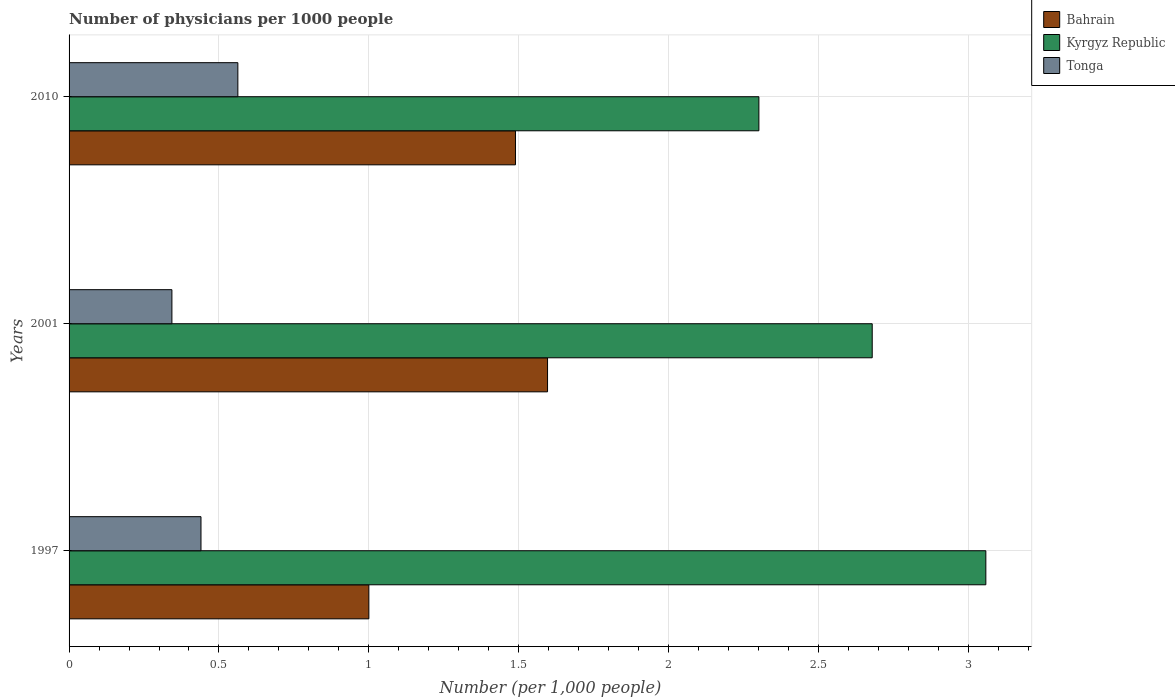How many groups of bars are there?
Your answer should be very brief. 3. Are the number of bars per tick equal to the number of legend labels?
Provide a succinct answer. Yes. What is the label of the 1st group of bars from the top?
Your answer should be compact. 2010. In how many cases, is the number of bars for a given year not equal to the number of legend labels?
Provide a short and direct response. 0. What is the number of physicians in Kyrgyz Republic in 1997?
Provide a succinct answer. 3.06. Across all years, what is the maximum number of physicians in Kyrgyz Republic?
Give a very brief answer. 3.06. Across all years, what is the minimum number of physicians in Kyrgyz Republic?
Provide a succinct answer. 2.3. In which year was the number of physicians in Tonga maximum?
Give a very brief answer. 2010. In which year was the number of physicians in Kyrgyz Republic minimum?
Your answer should be compact. 2010. What is the total number of physicians in Kyrgyz Republic in the graph?
Make the answer very short. 8.04. What is the difference between the number of physicians in Kyrgyz Republic in 2001 and that in 2010?
Provide a short and direct response. 0.38. What is the difference between the number of physicians in Kyrgyz Republic in 1997 and the number of physicians in Bahrain in 2001?
Offer a terse response. 1.46. What is the average number of physicians in Tonga per year?
Keep it short and to the point. 0.45. In the year 2010, what is the difference between the number of physicians in Bahrain and number of physicians in Kyrgyz Republic?
Offer a very short reply. -0.81. What is the ratio of the number of physicians in Tonga in 1997 to that in 2010?
Keep it short and to the point. 0.78. Is the difference between the number of physicians in Bahrain in 1997 and 2001 greater than the difference between the number of physicians in Kyrgyz Republic in 1997 and 2001?
Keep it short and to the point. No. What is the difference between the highest and the second highest number of physicians in Tonga?
Provide a succinct answer. 0.12. What is the difference between the highest and the lowest number of physicians in Tonga?
Keep it short and to the point. 0.22. In how many years, is the number of physicians in Kyrgyz Republic greater than the average number of physicians in Kyrgyz Republic taken over all years?
Your answer should be compact. 1. Is the sum of the number of physicians in Bahrain in 2001 and 2010 greater than the maximum number of physicians in Tonga across all years?
Provide a short and direct response. Yes. What does the 1st bar from the top in 1997 represents?
Keep it short and to the point. Tonga. What does the 2nd bar from the bottom in 1997 represents?
Ensure brevity in your answer.  Kyrgyz Republic. Is it the case that in every year, the sum of the number of physicians in Bahrain and number of physicians in Kyrgyz Republic is greater than the number of physicians in Tonga?
Provide a succinct answer. Yes. How many bars are there?
Ensure brevity in your answer.  9. Are all the bars in the graph horizontal?
Provide a succinct answer. Yes. What is the difference between two consecutive major ticks on the X-axis?
Provide a succinct answer. 0.5. Does the graph contain grids?
Make the answer very short. Yes. Where does the legend appear in the graph?
Ensure brevity in your answer.  Top right. What is the title of the graph?
Offer a terse response. Number of physicians per 1000 people. What is the label or title of the X-axis?
Your response must be concise. Number (per 1,0 people). What is the label or title of the Y-axis?
Provide a succinct answer. Years. What is the Number (per 1,000 people) in Bahrain in 1997?
Your answer should be very brief. 1. What is the Number (per 1,000 people) in Kyrgyz Republic in 1997?
Keep it short and to the point. 3.06. What is the Number (per 1,000 people) in Tonga in 1997?
Ensure brevity in your answer.  0.44. What is the Number (per 1,000 people) in Bahrain in 2001?
Your answer should be very brief. 1.6. What is the Number (per 1,000 people) of Kyrgyz Republic in 2001?
Offer a very short reply. 2.68. What is the Number (per 1,000 people) of Tonga in 2001?
Keep it short and to the point. 0.34. What is the Number (per 1,000 people) of Bahrain in 2010?
Give a very brief answer. 1.49. What is the Number (per 1,000 people) of Kyrgyz Republic in 2010?
Offer a very short reply. 2.3. What is the Number (per 1,000 people) of Tonga in 2010?
Ensure brevity in your answer.  0.56. Across all years, what is the maximum Number (per 1,000 people) of Bahrain?
Make the answer very short. 1.6. Across all years, what is the maximum Number (per 1,000 people) in Kyrgyz Republic?
Make the answer very short. 3.06. Across all years, what is the maximum Number (per 1,000 people) of Tonga?
Your response must be concise. 0.56. Across all years, what is the minimum Number (per 1,000 people) in Kyrgyz Republic?
Your answer should be very brief. 2.3. Across all years, what is the minimum Number (per 1,000 people) in Tonga?
Provide a short and direct response. 0.34. What is the total Number (per 1,000 people) of Bahrain in the graph?
Make the answer very short. 4.08. What is the total Number (per 1,000 people) in Kyrgyz Republic in the graph?
Your response must be concise. 8.04. What is the total Number (per 1,000 people) in Tonga in the graph?
Your answer should be very brief. 1.35. What is the difference between the Number (per 1,000 people) of Bahrain in 1997 and that in 2001?
Provide a short and direct response. -0.6. What is the difference between the Number (per 1,000 people) of Kyrgyz Republic in 1997 and that in 2001?
Your answer should be compact. 0.38. What is the difference between the Number (per 1,000 people) of Tonga in 1997 and that in 2001?
Make the answer very short. 0.1. What is the difference between the Number (per 1,000 people) of Bahrain in 1997 and that in 2010?
Your answer should be compact. -0.49. What is the difference between the Number (per 1,000 people) in Kyrgyz Republic in 1997 and that in 2010?
Provide a short and direct response. 0.76. What is the difference between the Number (per 1,000 people) of Tonga in 1997 and that in 2010?
Provide a succinct answer. -0.12. What is the difference between the Number (per 1,000 people) in Bahrain in 2001 and that in 2010?
Ensure brevity in your answer.  0.11. What is the difference between the Number (per 1,000 people) of Kyrgyz Republic in 2001 and that in 2010?
Provide a succinct answer. 0.38. What is the difference between the Number (per 1,000 people) of Tonga in 2001 and that in 2010?
Your response must be concise. -0.22. What is the difference between the Number (per 1,000 people) in Bahrain in 1997 and the Number (per 1,000 people) in Kyrgyz Republic in 2001?
Provide a succinct answer. -1.68. What is the difference between the Number (per 1,000 people) of Bahrain in 1997 and the Number (per 1,000 people) of Tonga in 2001?
Make the answer very short. 0.66. What is the difference between the Number (per 1,000 people) in Kyrgyz Republic in 1997 and the Number (per 1,000 people) in Tonga in 2001?
Keep it short and to the point. 2.71. What is the difference between the Number (per 1,000 people) in Bahrain in 1997 and the Number (per 1,000 people) in Kyrgyz Republic in 2010?
Provide a short and direct response. -1.3. What is the difference between the Number (per 1,000 people) in Bahrain in 1997 and the Number (per 1,000 people) in Tonga in 2010?
Make the answer very short. 0.44. What is the difference between the Number (per 1,000 people) in Kyrgyz Republic in 1997 and the Number (per 1,000 people) in Tonga in 2010?
Provide a short and direct response. 2.5. What is the difference between the Number (per 1,000 people) in Bahrain in 2001 and the Number (per 1,000 people) in Kyrgyz Republic in 2010?
Make the answer very short. -0.7. What is the difference between the Number (per 1,000 people) of Bahrain in 2001 and the Number (per 1,000 people) of Tonga in 2010?
Give a very brief answer. 1.03. What is the difference between the Number (per 1,000 people) in Kyrgyz Republic in 2001 and the Number (per 1,000 people) in Tonga in 2010?
Your response must be concise. 2.12. What is the average Number (per 1,000 people) of Bahrain per year?
Your answer should be very brief. 1.36. What is the average Number (per 1,000 people) of Kyrgyz Republic per year?
Keep it short and to the point. 2.68. What is the average Number (per 1,000 people) of Tonga per year?
Offer a very short reply. 0.45. In the year 1997, what is the difference between the Number (per 1,000 people) in Bahrain and Number (per 1,000 people) in Kyrgyz Republic?
Ensure brevity in your answer.  -2.06. In the year 1997, what is the difference between the Number (per 1,000 people) of Bahrain and Number (per 1,000 people) of Tonga?
Offer a terse response. 0.56. In the year 1997, what is the difference between the Number (per 1,000 people) of Kyrgyz Republic and Number (per 1,000 people) of Tonga?
Make the answer very short. 2.62. In the year 2001, what is the difference between the Number (per 1,000 people) of Bahrain and Number (per 1,000 people) of Kyrgyz Republic?
Your answer should be very brief. -1.08. In the year 2001, what is the difference between the Number (per 1,000 people) in Bahrain and Number (per 1,000 people) in Tonga?
Your answer should be compact. 1.25. In the year 2001, what is the difference between the Number (per 1,000 people) in Kyrgyz Republic and Number (per 1,000 people) in Tonga?
Make the answer very short. 2.34. In the year 2010, what is the difference between the Number (per 1,000 people) of Bahrain and Number (per 1,000 people) of Kyrgyz Republic?
Your response must be concise. -0.81. In the year 2010, what is the difference between the Number (per 1,000 people) in Bahrain and Number (per 1,000 people) in Tonga?
Keep it short and to the point. 0.93. In the year 2010, what is the difference between the Number (per 1,000 people) in Kyrgyz Republic and Number (per 1,000 people) in Tonga?
Provide a succinct answer. 1.74. What is the ratio of the Number (per 1,000 people) of Bahrain in 1997 to that in 2001?
Your response must be concise. 0.63. What is the ratio of the Number (per 1,000 people) in Kyrgyz Republic in 1997 to that in 2001?
Ensure brevity in your answer.  1.14. What is the ratio of the Number (per 1,000 people) of Tonga in 1997 to that in 2001?
Your answer should be very brief. 1.28. What is the ratio of the Number (per 1,000 people) in Bahrain in 1997 to that in 2010?
Keep it short and to the point. 0.67. What is the ratio of the Number (per 1,000 people) of Kyrgyz Republic in 1997 to that in 2010?
Your answer should be very brief. 1.33. What is the ratio of the Number (per 1,000 people) in Tonga in 1997 to that in 2010?
Offer a terse response. 0.78. What is the ratio of the Number (per 1,000 people) of Bahrain in 2001 to that in 2010?
Provide a succinct answer. 1.07. What is the ratio of the Number (per 1,000 people) in Kyrgyz Republic in 2001 to that in 2010?
Provide a short and direct response. 1.16. What is the ratio of the Number (per 1,000 people) of Tonga in 2001 to that in 2010?
Your answer should be compact. 0.61. What is the difference between the highest and the second highest Number (per 1,000 people) of Bahrain?
Your response must be concise. 0.11. What is the difference between the highest and the second highest Number (per 1,000 people) in Kyrgyz Republic?
Your answer should be compact. 0.38. What is the difference between the highest and the second highest Number (per 1,000 people) in Tonga?
Your response must be concise. 0.12. What is the difference between the highest and the lowest Number (per 1,000 people) in Bahrain?
Offer a very short reply. 0.6. What is the difference between the highest and the lowest Number (per 1,000 people) of Kyrgyz Republic?
Offer a very short reply. 0.76. What is the difference between the highest and the lowest Number (per 1,000 people) in Tonga?
Offer a very short reply. 0.22. 